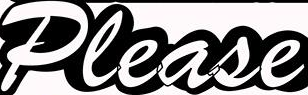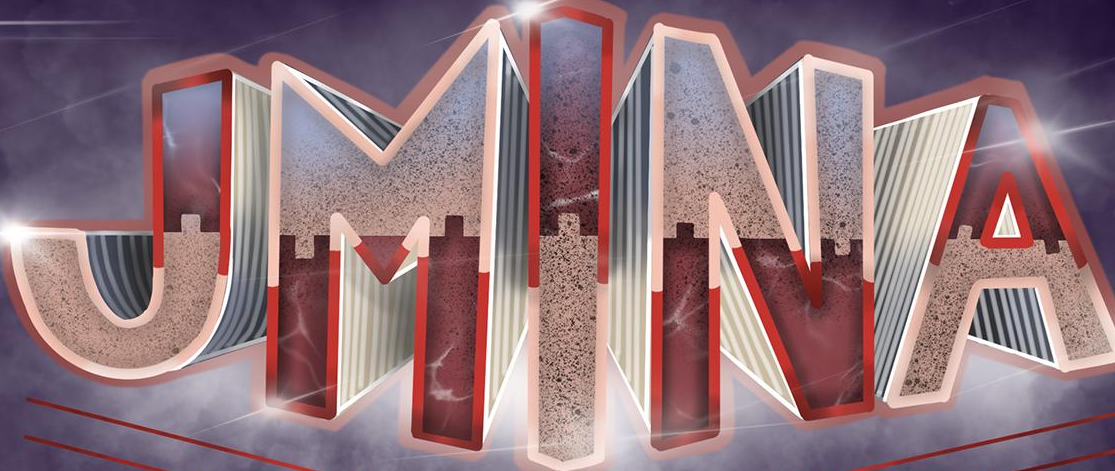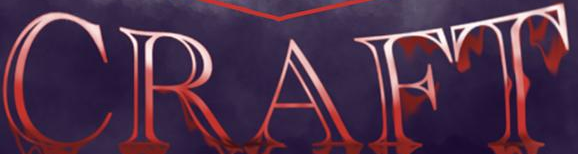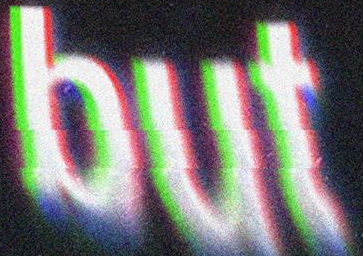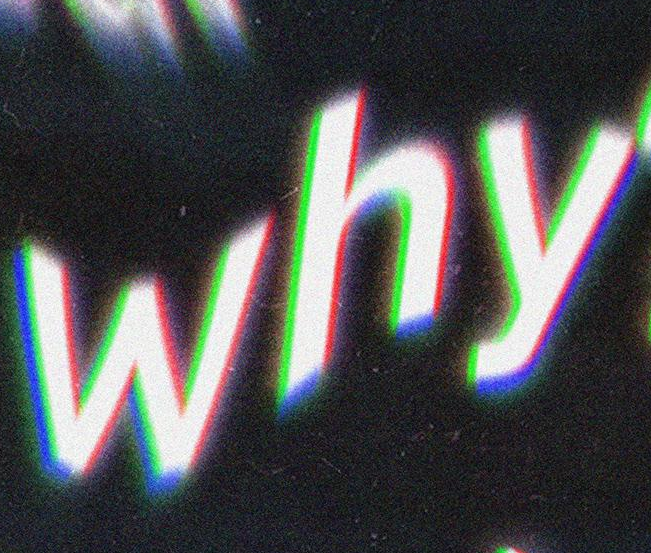What text is displayed in these images sequentially, separated by a semicolon? Please; JMINA; CRAFT; but; why 